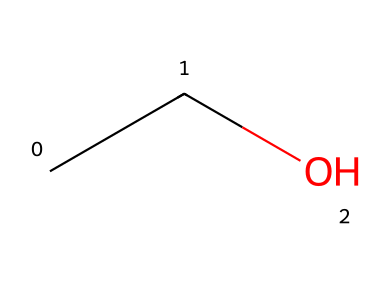What is the molecular formula of this chemical? The SMILES representation "CCO" indicates three atoms: two carbon (C) atoms and one oxygen (O) atom. Thus, the molecular formula includes these elements, which is C2H6O when considering hydrogen atoms normally bonded to carbon and oxygen.
Answer: C2H6O How many carbon atoms are in this molecule? The SMILES "CCO" shows two 'C' characters at the beginning, representing two carbon atoms.
Answer: 2 What type of chemical bond primarily exists in this molecule? The structure "CCO" involves carbon-carbon and carbon-oxygen single covalent bonds. Since no double or triple bonds are indicated, the primary type is single bonds.
Answer: single Is this chemical an organic compound? The presence of carbon atoms (in this case, two) indicates that this molecule is organic, as all organic compounds contain carbon.
Answer: yes What type of solvent properties does this molecule exhibit? Ethanol, as indicated by the SMILES representation "CCO", is a non-electrolyte and a polar solvent, typically soluble in water due to its ability to form hydrogen bonds, not ionizing in solution.
Answer: non-electrolyte How can this molecule be classified based on its solubility behavior? Ethanol is a non-electrolyte, characterized by its inability to dissociate into ions in solution, which reflects its solubility property as it can dissolve in polar solvents while remaining unchanged.
Answer: non-electrolyte 